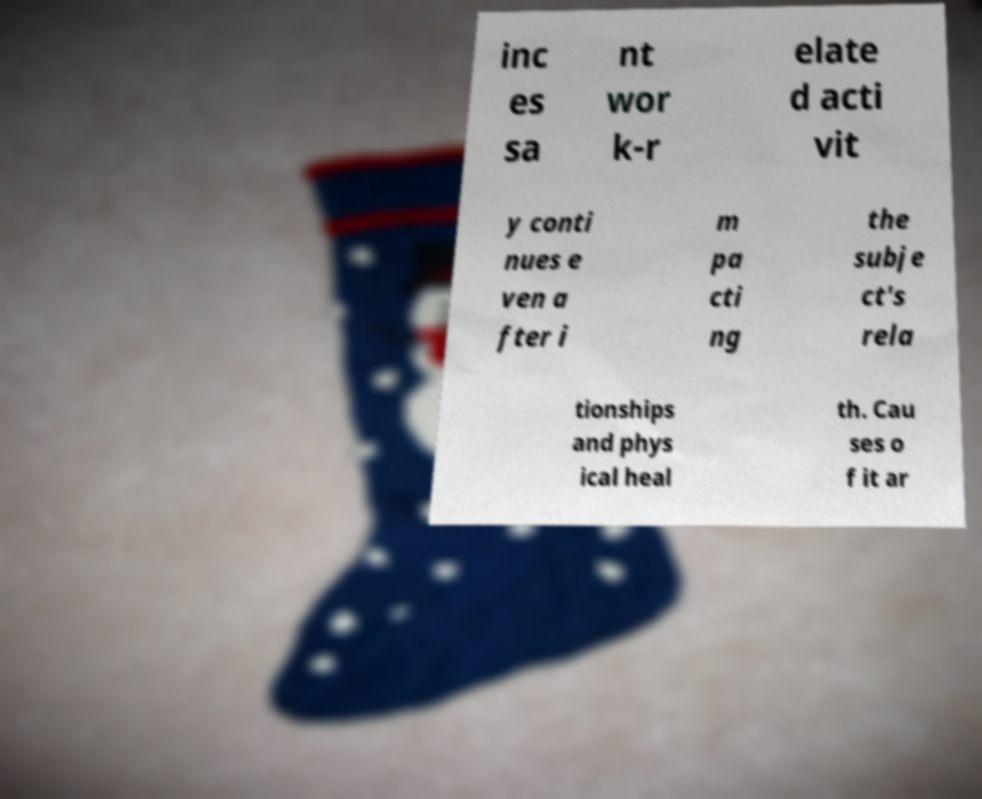I need the written content from this picture converted into text. Can you do that? inc es sa nt wor k-r elate d acti vit y conti nues e ven a fter i m pa cti ng the subje ct's rela tionships and phys ical heal th. Cau ses o f it ar 